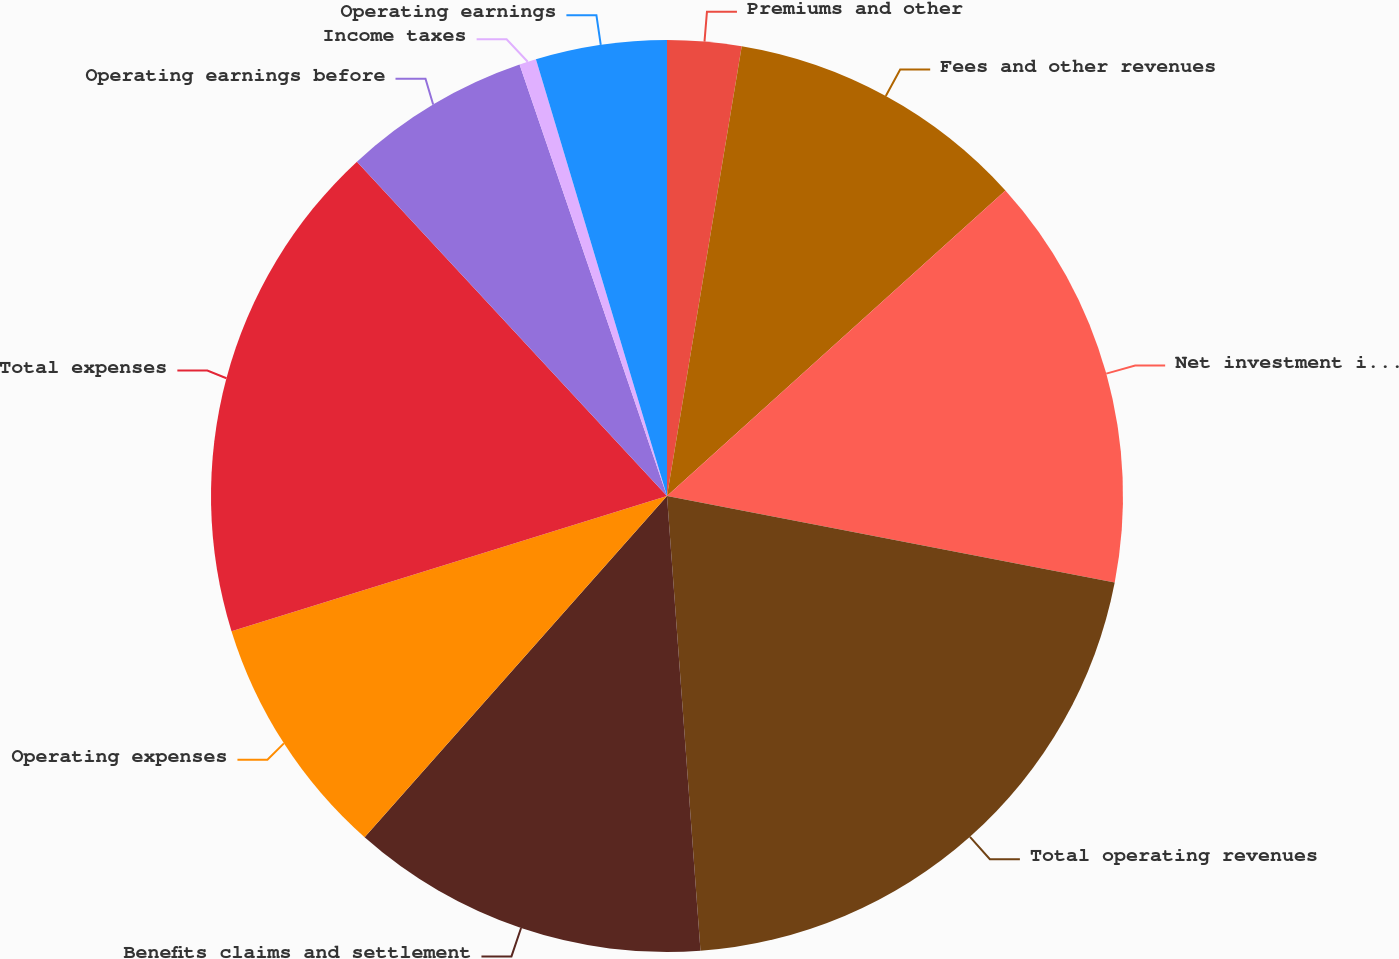Convert chart. <chart><loc_0><loc_0><loc_500><loc_500><pie_chart><fcel>Premiums and other<fcel>Fees and other revenues<fcel>Net investment income<fcel>Total operating revenues<fcel>Benefits claims and settlement<fcel>Operating expenses<fcel>Total expenses<fcel>Operating earnings before<fcel>Income taxes<fcel>Operating earnings<nl><fcel>2.62%<fcel>10.69%<fcel>14.73%<fcel>20.79%<fcel>12.71%<fcel>8.67%<fcel>17.89%<fcel>6.66%<fcel>0.6%<fcel>4.64%<nl></chart> 